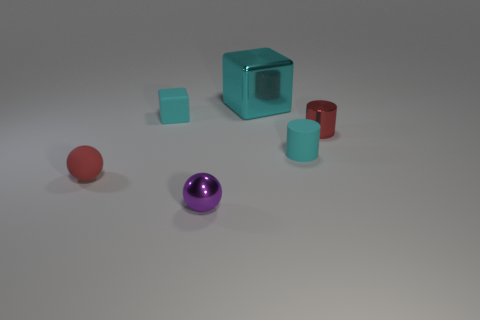Add 4 tiny purple metallic things. How many objects exist? 10 Subtract all blocks. How many objects are left? 4 Subtract all large metallic blocks. Subtract all big things. How many objects are left? 4 Add 5 cubes. How many cubes are left? 7 Add 1 tiny red rubber things. How many tiny red rubber things exist? 2 Subtract 1 red balls. How many objects are left? 5 